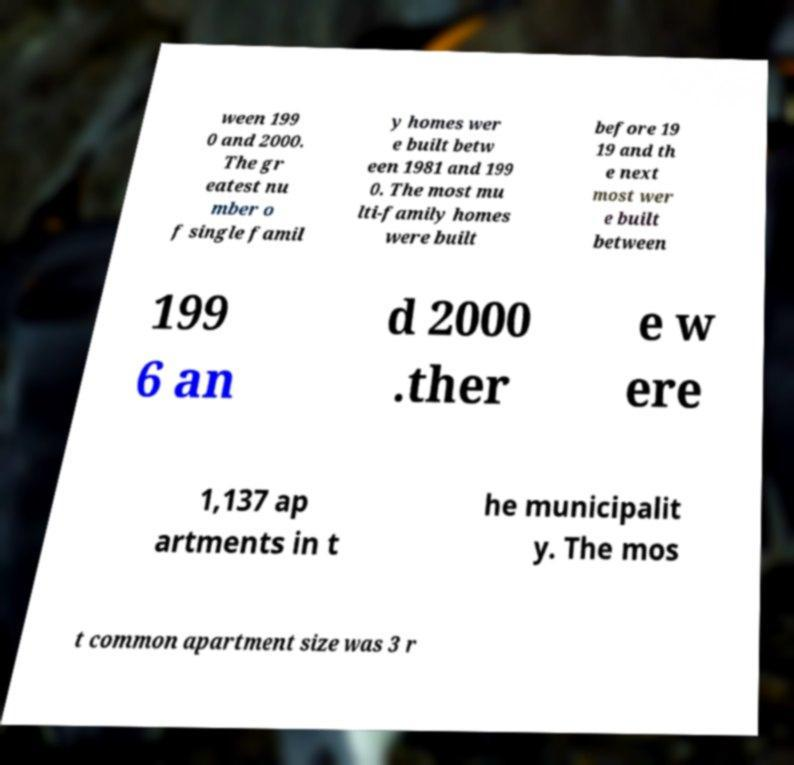Please identify and transcribe the text found in this image. ween 199 0 and 2000. The gr eatest nu mber o f single famil y homes wer e built betw een 1981 and 199 0. The most mu lti-family homes were built before 19 19 and th e next most wer e built between 199 6 an d 2000 .ther e w ere 1,137 ap artments in t he municipalit y. The mos t common apartment size was 3 r 